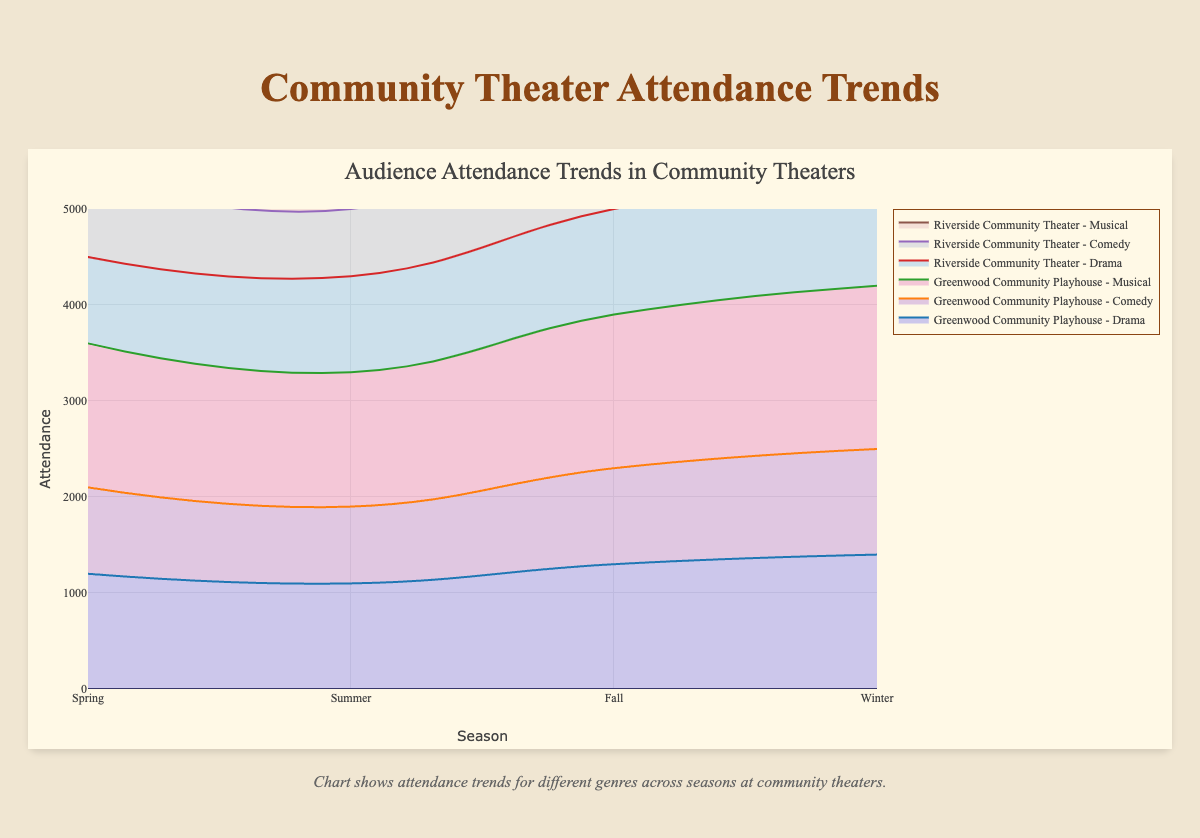Which season sees the highest attendance for musicals at Greenwood Community Playhouse? Look at the area chart for Greenwood Community Playhouse and identify the points on the x-axis labeled "Musical". Compare the heights of the y-axis values for each season. Winter has the highest y-axis value for musicals.
Answer: Winter Which theater has higher overall attendance for dramas in the Fall, Greenwood or Riverside? Look at the area corresponding to "Drama" for the Fall season for both theaters. Compare the y-axis values – Greenwood shows 1300 and Riverside shows 1100 for dramas in the Fall.
Answer: Greenwood How does the attendance for comedies in the Summer at Riverside Community Theater compare to that of Greenwood Community Playhouse? Identify the points on the x-axis labeled "Comedy" for the Summer season for both theaters. Compare their y-axis values – Greenwood has an attendance of 800 while Riverside has 700.
Answer: 100 higher at Greenwood What is the total attendance for musicals in all seasons at Riverside Community Theater? Summing the y-axis values for "Musical" in each season at Riverside Community Theater: 1100 (Spring) + 1200 (Summer) + 1300 (Fall) + 1400 (Winter).
Answer: 5000 Which genre shows the most significant attendance increase from Spring to Winter at Greenwood Community Playhouse? Compare the y-axis values for "Drama", "Comedy", and "Musical" from Spring to Winter. "Musical" increases from 1500 in Spring to 1700 in Winter, which is the highest increase among the genres.
Answer: Musical What's the average audience attendance for comedies over all seasons at both theaters? Sum the y-axis values for "Comedy" across all seasons for both theaters and then divide by the total number of seasons (8 sums in total, as it's across 2 theaters): (900 + 800 + 1000 + 1100 + 800 + 700 + 900 + 950) / 8.
Answer: 893.75 During which season is the overall attendance for all genres the lowest at Riverside Community Theater? Sum the attendance for "Drama," "Comedy," and "Musical" for each season at Riverside Community Theater and identify the lowest total.
Answer: Summer Is the trend for musical attendance over the seasons the same for both Greenwood and Riverside? Compare the trend lines for "Musical" in both theaters. Both lines show similar seasonal patterns: an increase from Spring to Winter.
Answer: Yes 